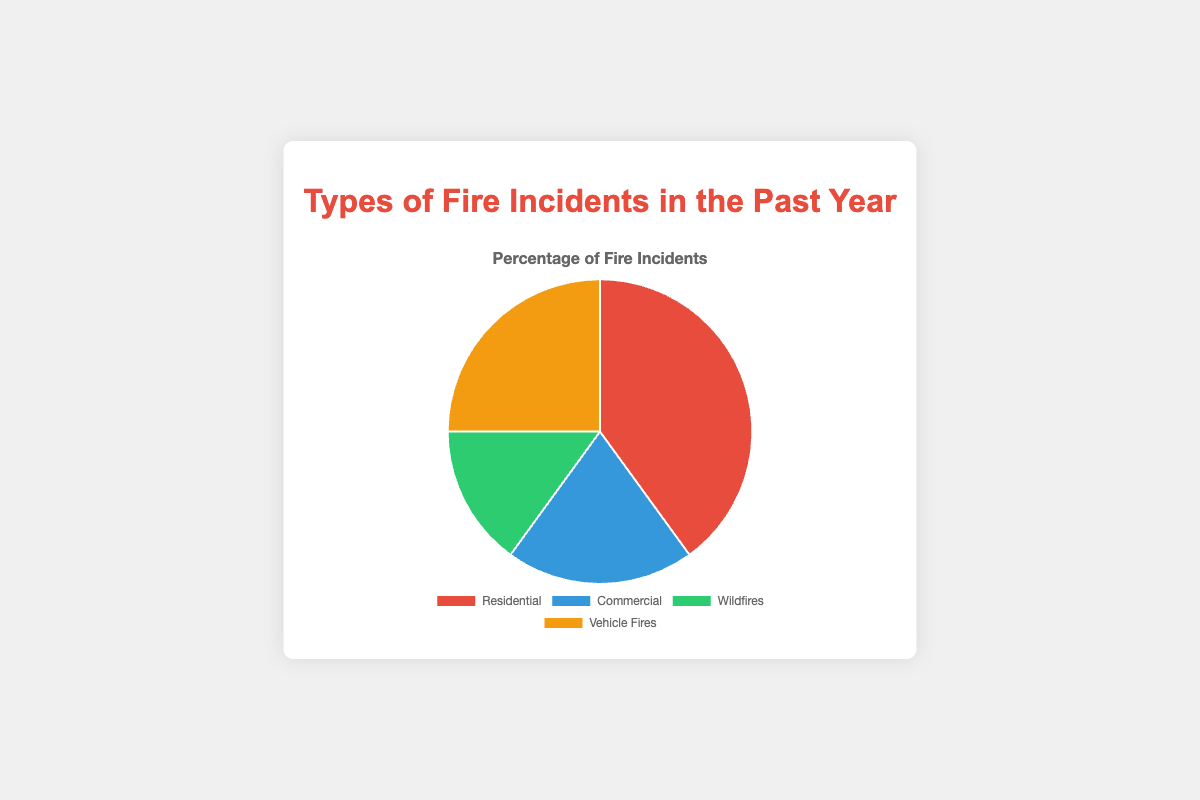What is the most common type of fire incident? The pie chart shows that Residential fires constitute 40% of the incidents, which is the highest percentage among the four types.
Answer: Residential Which type of fire incidents is the least common? According to the pie chart, Wildfires make up 15% of the incidents, which is the lowest percentage.
Answer: Wildfires What is the difference in the number of incidents between Residential and Commercial fires? The Residential fires constitute 40%, and Commercial fires make up 20%. The difference is 40% - 20% = 20%. In terms of incidents, Resident fires are 120, and Commercial fires are 60. The difference is 120 - 60 = 60 incidents.
Answer: 60 incidents If you combine the incidents of Commercial and Vehicle Fires, what percentage of the total does that represent? Commercial fires are 20% and Vehicle fires are 25%. Adding them together gives 20% + 25% = 45%.
Answer: 45% How much larger is the percentage of Residential fires compared to Wildfires? Residential fires are 40%, and Wildfires are 15%. The difference is 40% - 15% = 25%.
Answer: 25% What percentage of incidents are not Residential fires? Residential fires make up 40%, so the percentage of incidents that are not Residential fires is 100% - 40% = 60%.
Answer: 60% If a new category of Electrical Fires were added that accounted for 10% of the total incidents, what would be the new percentage for Wildfires? If Electrical Fires take up 10%, the total percentage becomes 100% + 10% = 110%. To normalize, the total must remain at 100%. First, let's adjust the 15% Wildfire share: Wildfires would then be (15/110) * 100% = approximately 13.64%.
Answer: ~13.64% Among Commercial and Vehicle fires, which type has more incidents and by how many? Vehicle fires account for 25% while Commercial fires account for 20%. Incidents are 75 for Vehicle and 60 for Commercial. The difference is 75 - 60 = 15 incidents.
Answer: Vehicle fires by 15 incidents 